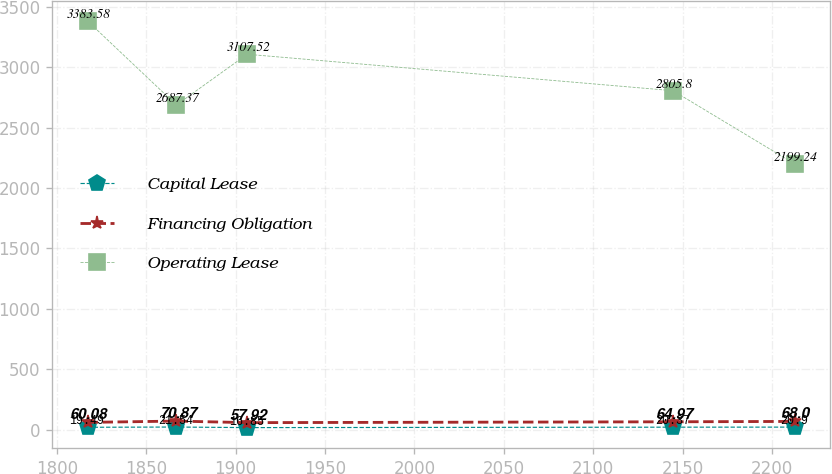<chart> <loc_0><loc_0><loc_500><loc_500><line_chart><ecel><fcel>Capital Lease<fcel>Financing Obligation<fcel>Operating Lease<nl><fcel>1817.21<fcel>19.49<fcel>60.08<fcel>3383.58<nl><fcel>1866.92<fcel>21.54<fcel>70.87<fcel>2687.37<nl><fcel>1906.46<fcel>16.85<fcel>57.92<fcel>3107.52<nl><fcel>2144.57<fcel>20.37<fcel>64.97<fcel>2805.8<nl><fcel>2212.57<fcel>20.9<fcel>68<fcel>2199.24<nl></chart> 